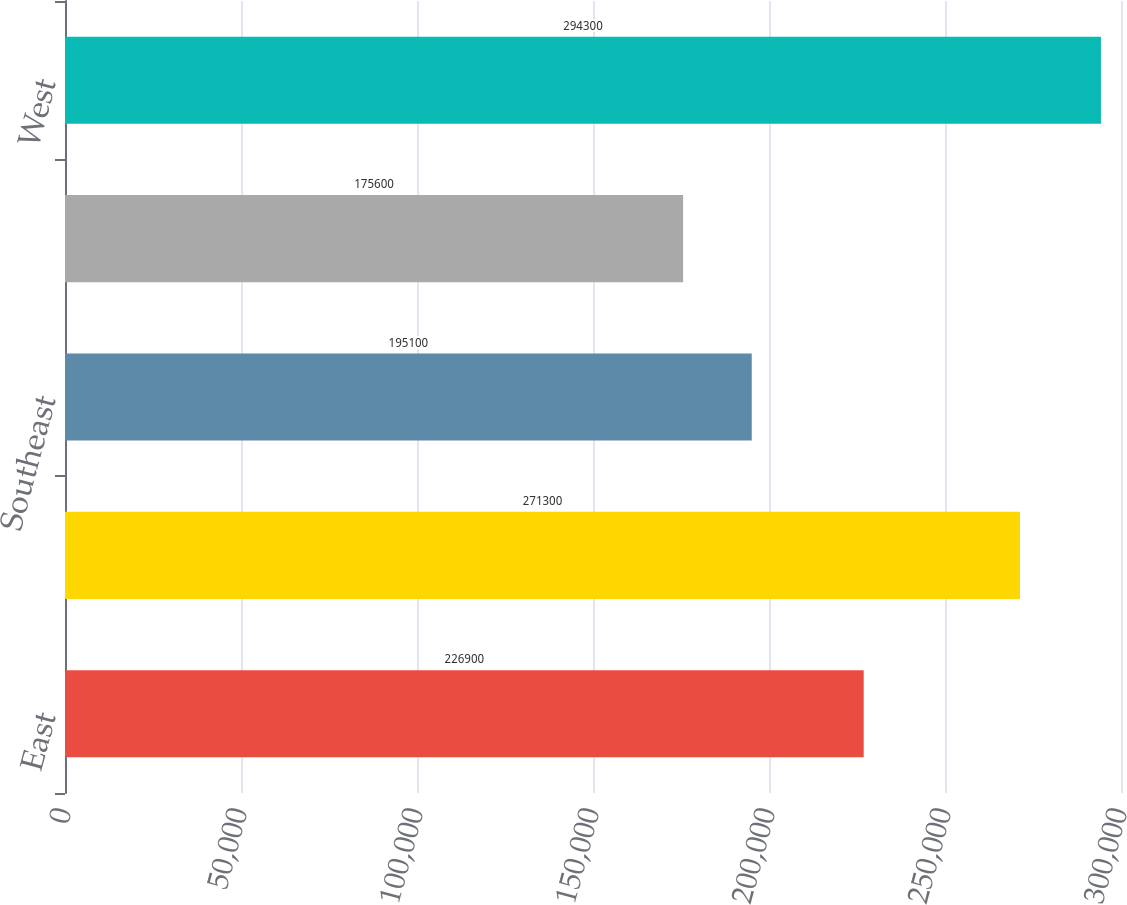Convert chart. <chart><loc_0><loc_0><loc_500><loc_500><bar_chart><fcel>East<fcel>Midwest<fcel>Southeast<fcel>South Central<fcel>West<nl><fcel>226900<fcel>271300<fcel>195100<fcel>175600<fcel>294300<nl></chart> 